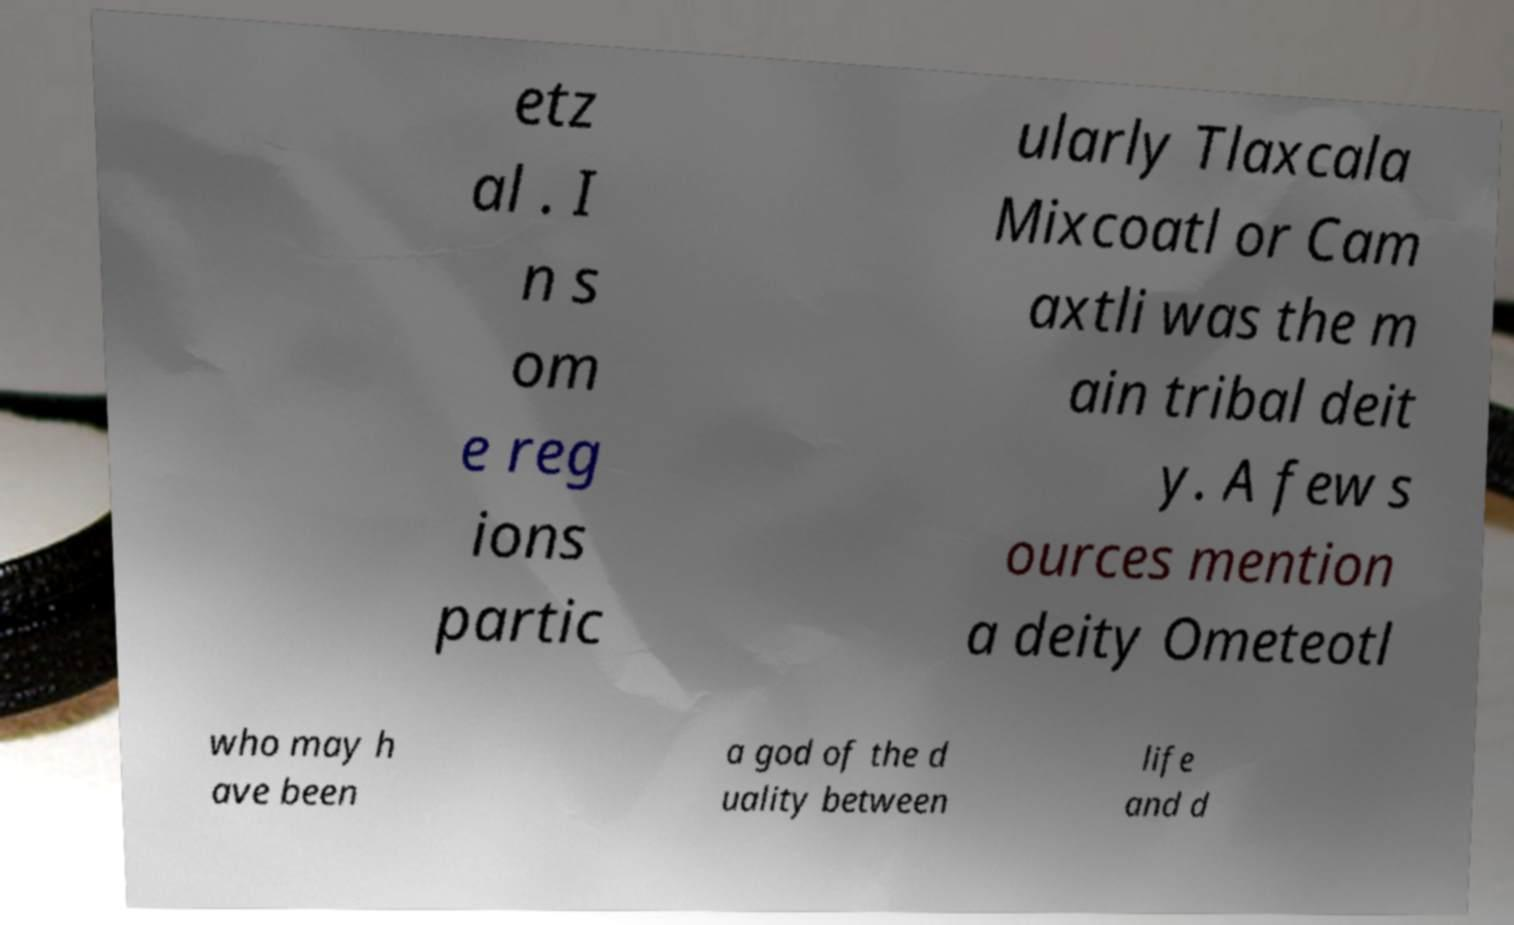Could you assist in decoding the text presented in this image and type it out clearly? etz al . I n s om e reg ions partic ularly Tlaxcala Mixcoatl or Cam axtli was the m ain tribal deit y. A few s ources mention a deity Ometeotl who may h ave been a god of the d uality between life and d 